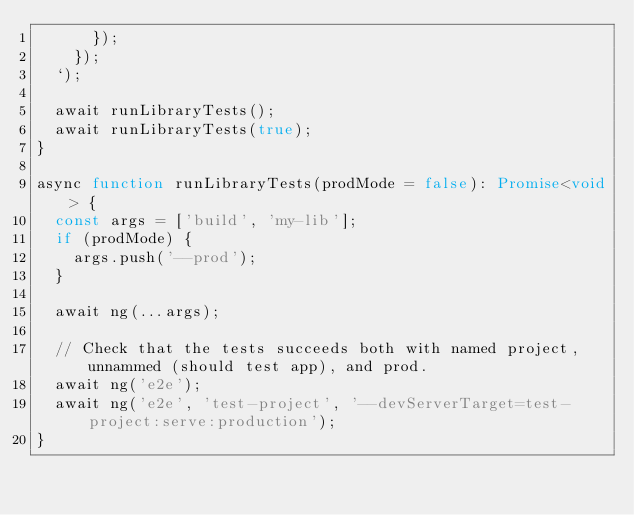<code> <loc_0><loc_0><loc_500><loc_500><_TypeScript_>      });
    });
  `);

  await runLibraryTests();
  await runLibraryTests(true);
}

async function runLibraryTests(prodMode = false): Promise<void> {
  const args = ['build', 'my-lib'];
  if (prodMode) {
    args.push('--prod');
  }

  await ng(...args);

  // Check that the tests succeeds both with named project, unnammed (should test app), and prod.
  await ng('e2e');
  await ng('e2e', 'test-project', '--devServerTarget=test-project:serve:production');
}
</code> 